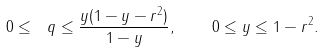Convert formula to latex. <formula><loc_0><loc_0><loc_500><loc_500>0 \leq \ q \leq \frac { y ( 1 - y - r ^ { 2 } ) } { 1 - y } , \quad 0 \leq y \leq 1 - r ^ { 2 } .</formula> 